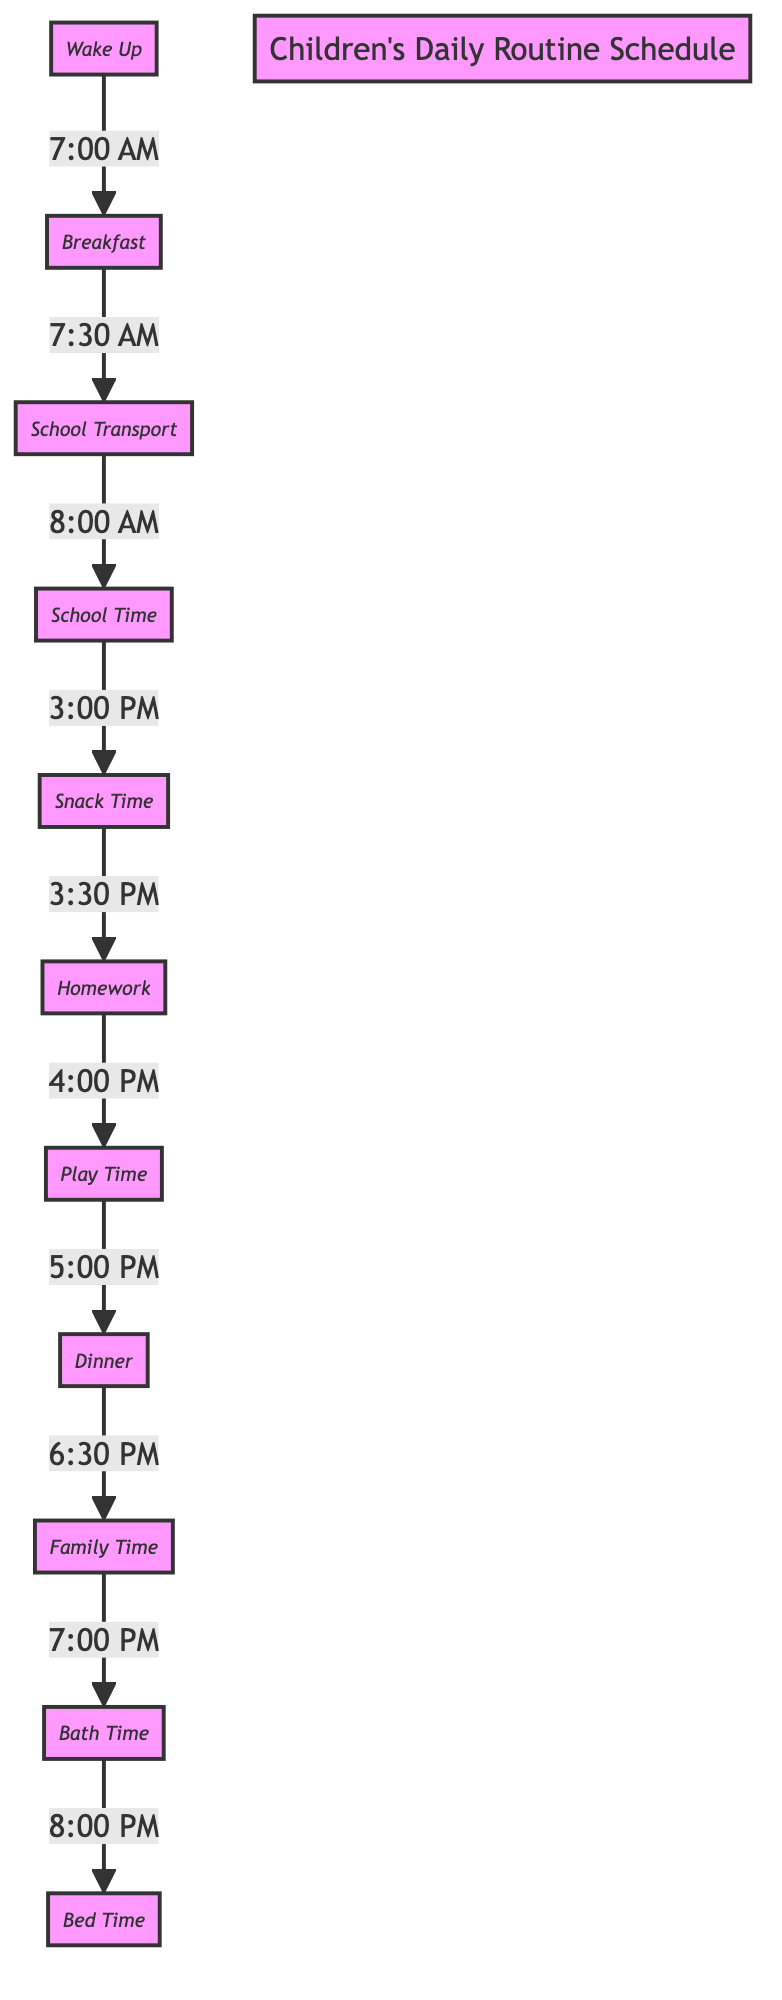What time does the family have dinner? According to the diagram, dinner is scheduled to start at 6:30 PM, making it clear when this activity takes place.
Answer: 6:30 PM How many activities are listed in the schedule? By counting the nodes in the diagram, there are a total of 10 activities listed, which include waking up, meal times, school, and family activities.
Answer: 10 What is the first activity after breakfast? Following breakfast in the flow of the diagram, the next activity is school transport, which occurs after breakfast.
Answer: School Transport What time does playtime start? The diagram shows that playtime begins at 4:00 PM, following the completion of homework.
Answer: 4:00 PM How long does the child spend on homework? Examining the timeline in the diagram, homework is listed from 3:30 PM to 4:00 PM, indicating a duration of 30 minutes.
Answer: 30 minutes What is the relationship between school and snack time? The diagram connects school to snack time by indicating that after school ends at 3:00 PM, snack time begins at 3:30 PM, showing a sequence of events.
Answer: Sequential What activity follows family time? After family time concludes at 7:00 PM, the diagram indicates that the next activity is bath time starting at 8:00 PM, establishing the order.
Answer: Bath Time At what time does the child wake up? The diagram explicitly states that the wake-up time is set for 7:00 AM, providing a clear start to the day's schedule.
Answer: 7:00 AM How many hours are between wake up and school time? Counting the time from wake up at 7:00 AM to school transport at 8:00 AM, there is a 1-hour interval in between both activities.
Answer: 1 hour 